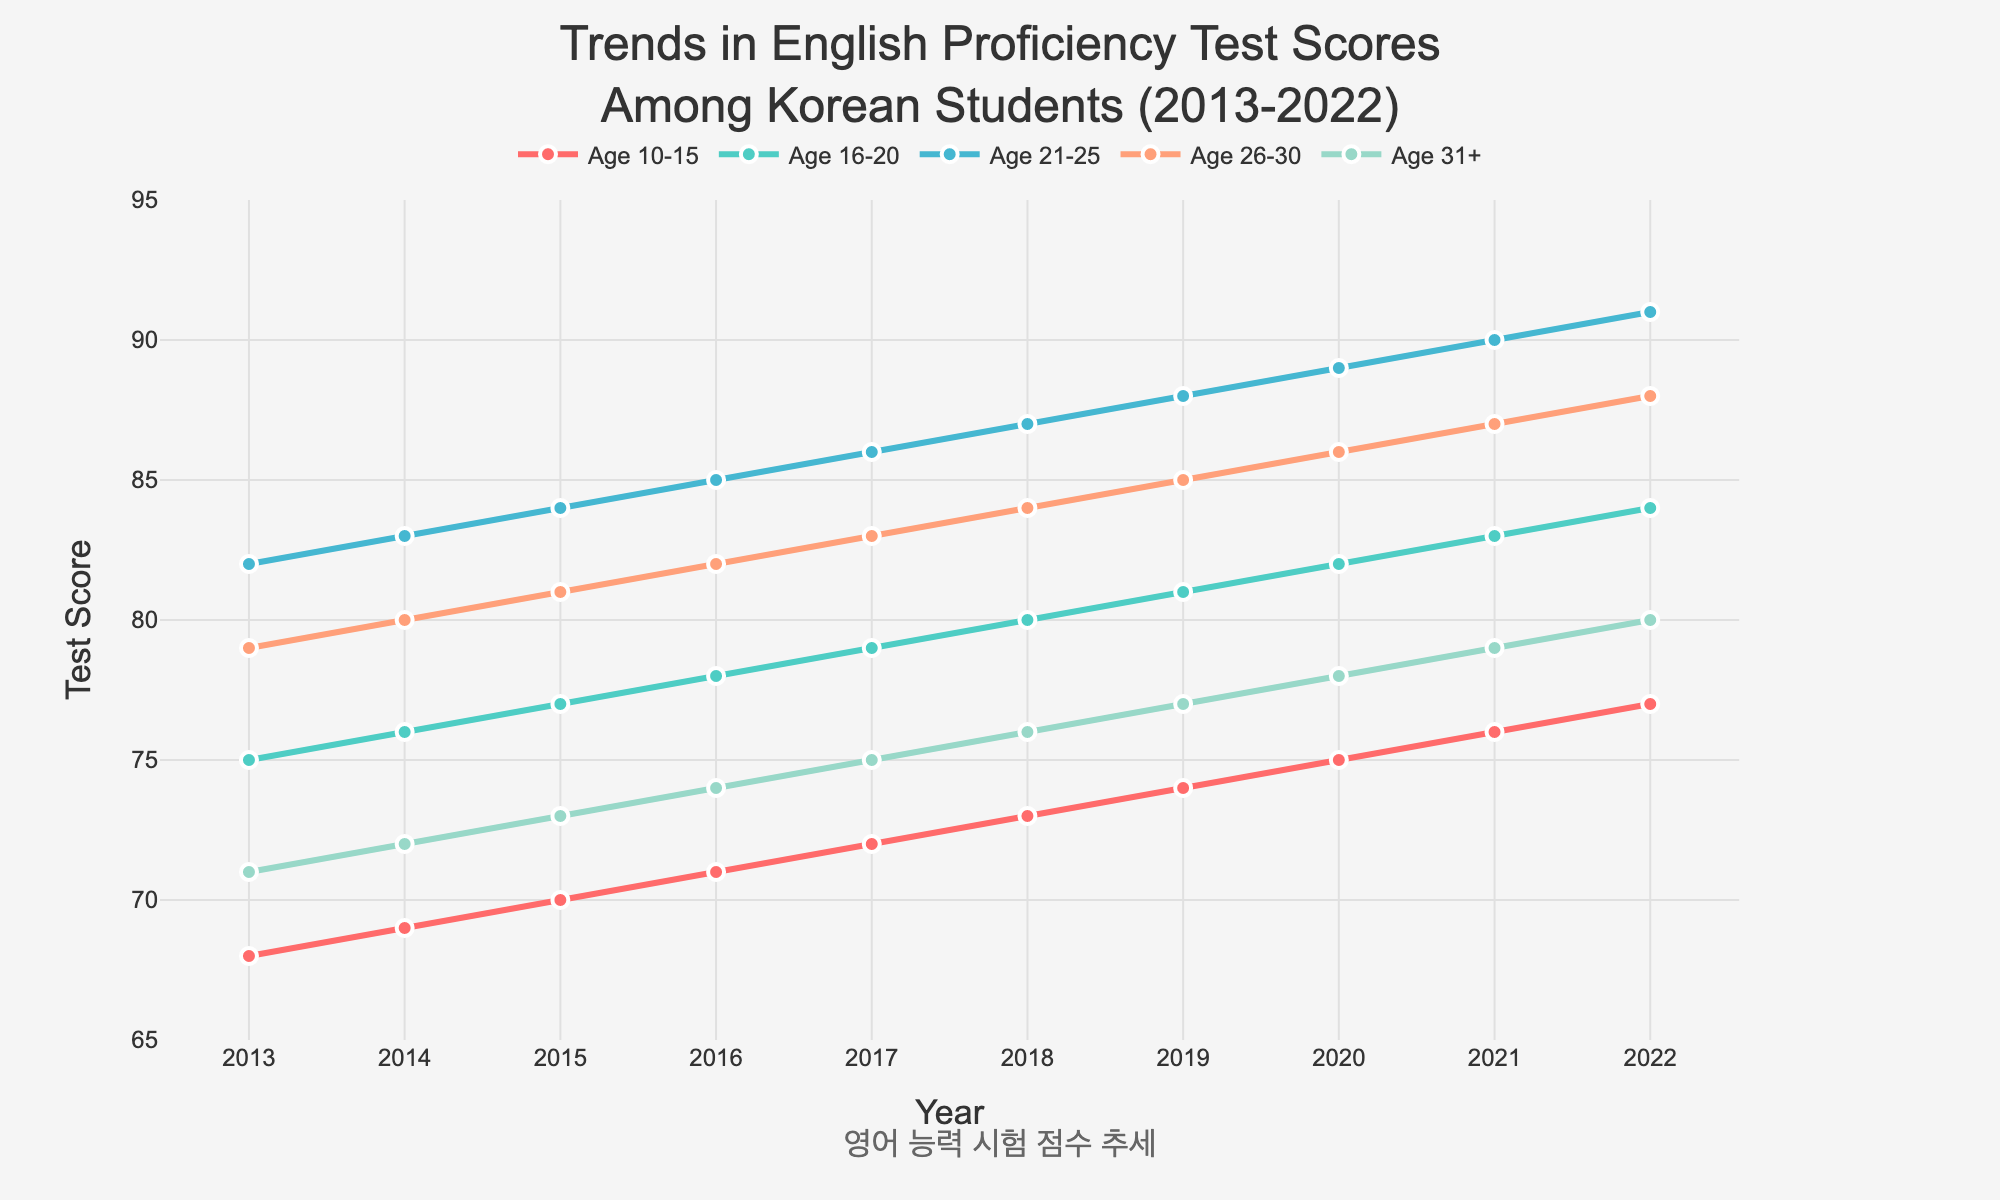What age group had the highest test scores in 2022? By examining the trend lines in the figure, the "Age 21-25" group had the highest test score in 2022, represented by the peak point at the end.
Answer: Age 21-25 How did the test scores of the "Age 16-20" group change from 2015 to 2020? Referencing the trend line for the "Age 16-20" group, the scores increased from 77 in 2015 to 82 in 2020. This is observed as an upward slope between these years.
Answer: Increased by 5 Which age group showed the most improvement in test scores over the decade? By comparing the starting and ending points of each trend line, "Age 26-30" group showed the most improvement, increasing from 79 in 2013 to 88 in 2022. This group had a net improvement of 9 points, the highest among all.
Answer: Age 26-30 What is the trend of test scores for the "Age 10-15" group from 2013 to 2022? Observing the trend line for "Age 10-15", the score consistently increased from 68 in 2013 to 77 in 2022. Each year shows an increment of 1 point, forming a steadily upward line.
Answer: Consistently increasing Over which years did the "Age 31+" group have a score equal to or greater than the "Age 16-20" group? By analyzing the overlapping points of the two trend lines, "Age 31+" group had scores equal to or greater than the "Age 16-20" group in 2013, 2014, and 2015. After 2015, "Age 16-20" consistently had higher scores.
Answer: 2013, 2014, 2015 What are the test score differences between the "Age 21-25" and "Age 31+" groups in 2020? According to the figure, in 2020, the "Age 21-25" group had a score of 89 and the "Age 31+" group had a score of 78. The difference is 89 - 78 = 11.
Answer: 11 Which age group had the lowest test score in 2019 and what was it? Observing the lowest points on the trend lines for 2019, the "Age 10-15" group had the lowest score, which was 74.
Answer: Age 10-15, 74 What is the average test score of the "Age 26-30" group over the decade? To calculate the average: add the test scores of "Age 26-30" from each year (79+80+81+82+83+84+85+86+87+88 = 835) and divide by the number of years (10). So, the average score is 835/10 = 83.5.
Answer: 83.5 How many age groups had their test scores increased by at least 8 points over the decade? Calculate the score differences for all groups over the recognized time frame: 
- Age 10-15: 77-68 = 9
- Age 16-20: 84-75 = 9
- Age 21-25: 91-82 = 9
- Age 26-30: 88-79 = 9
- Age 31+: 80-71 = 9
Each age group increased their scores by 8 or more points.
Answer: 5 Which age group had the least improvement in their test scores from 2015 to 2022? By calculating the differences for 2015 to 2022 for each group:
- Age 10-15: 77-70 = 7
- Age 16-20: 84-77 = 7
- Age 21-25: 91-84 = 7
- Age 26-30: 88-81 = 7
- Age 31+: 80-73 = 7
Each group had a 7-point difference, so none had fewer improvements. Recheck assumptions.
Answer: None 